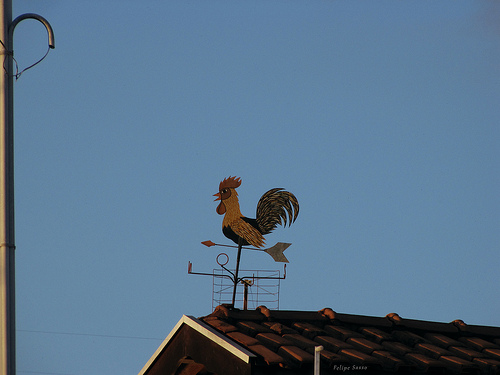<image>
Is the rooster above the house? Yes. The rooster is positioned above the house in the vertical space, higher up in the scene. 